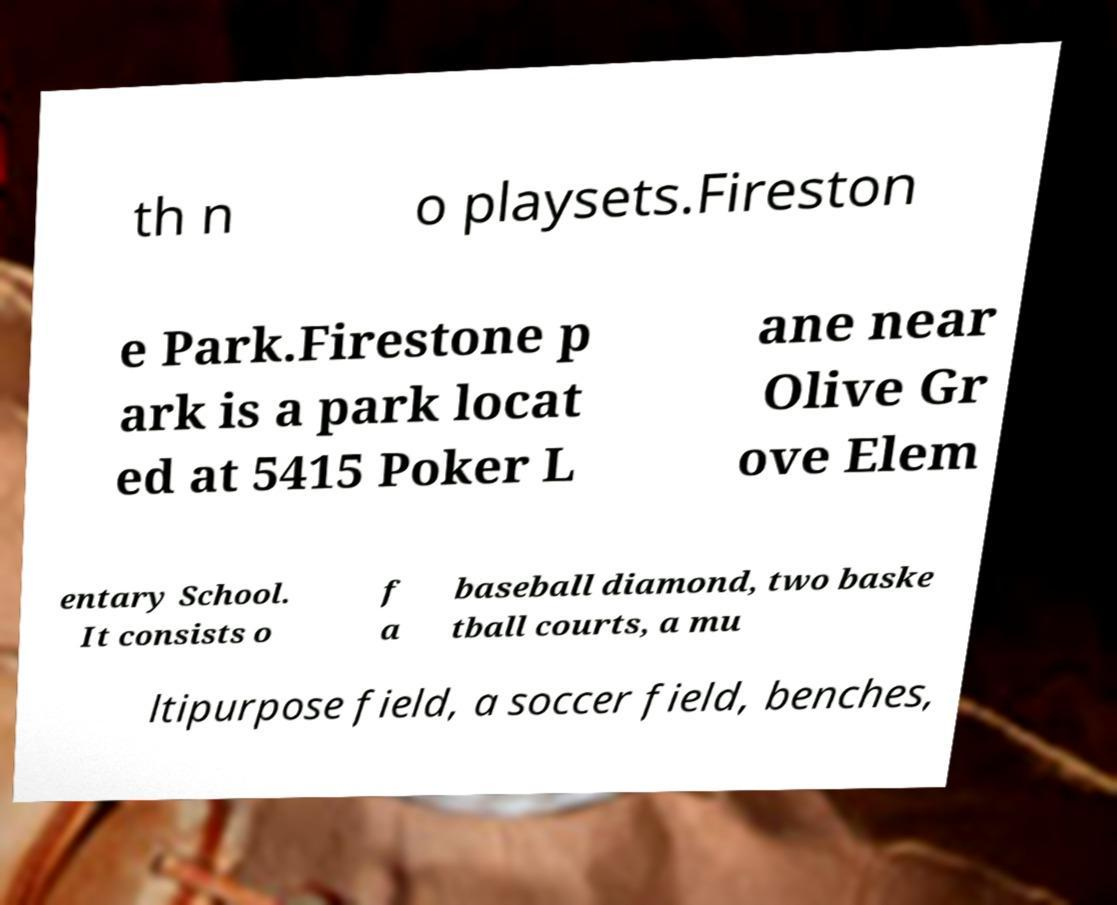Please read and relay the text visible in this image. What does it say? th n o playsets.Fireston e Park.Firestone p ark is a park locat ed at 5415 Poker L ane near Olive Gr ove Elem entary School. It consists o f a baseball diamond, two baske tball courts, a mu ltipurpose field, a soccer field, benches, 